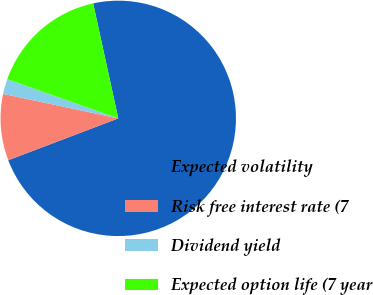<chart> <loc_0><loc_0><loc_500><loc_500><pie_chart><fcel>Expected volatility<fcel>Risk free interest rate (7<fcel>Dividend yield<fcel>Expected option life (7 year<nl><fcel>72.63%<fcel>9.12%<fcel>2.06%<fcel>16.18%<nl></chart> 